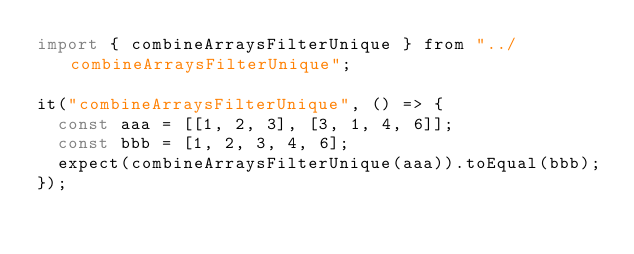Convert code to text. <code><loc_0><loc_0><loc_500><loc_500><_JavaScript_>import { combineArraysFilterUnique } from "../combineArraysFilterUnique";

it("combineArraysFilterUnique", () => {
  const aaa = [[1, 2, 3], [3, 1, 4, 6]];
  const bbb = [1, 2, 3, 4, 6];
  expect(combineArraysFilterUnique(aaa)).toEqual(bbb);
});
</code> 